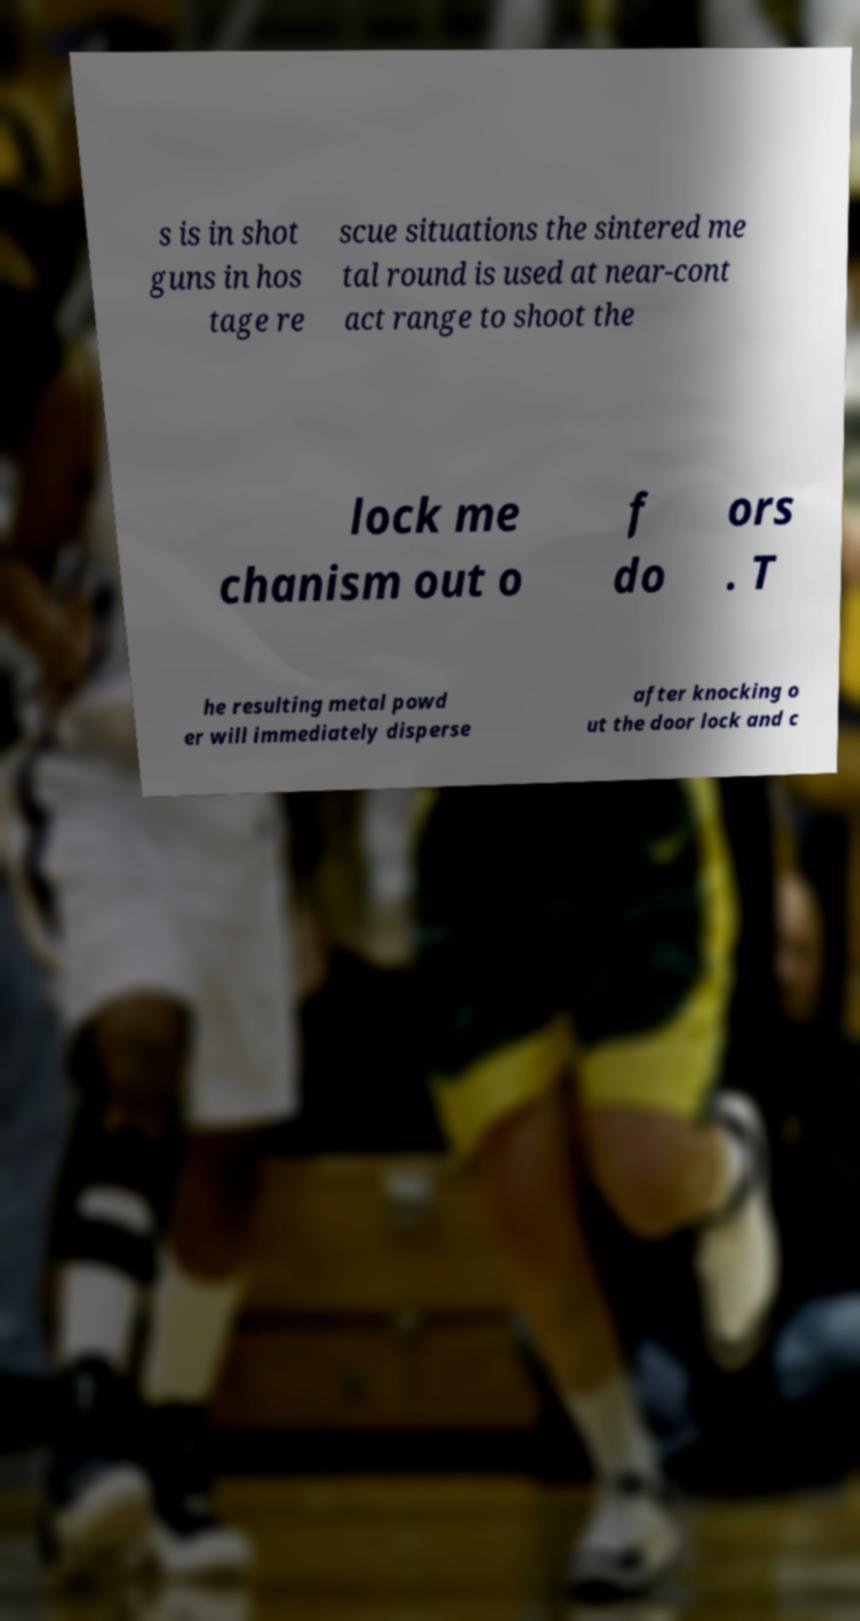Can you accurately transcribe the text from the provided image for me? s is in shot guns in hos tage re scue situations the sintered me tal round is used at near-cont act range to shoot the lock me chanism out o f do ors . T he resulting metal powd er will immediately disperse after knocking o ut the door lock and c 